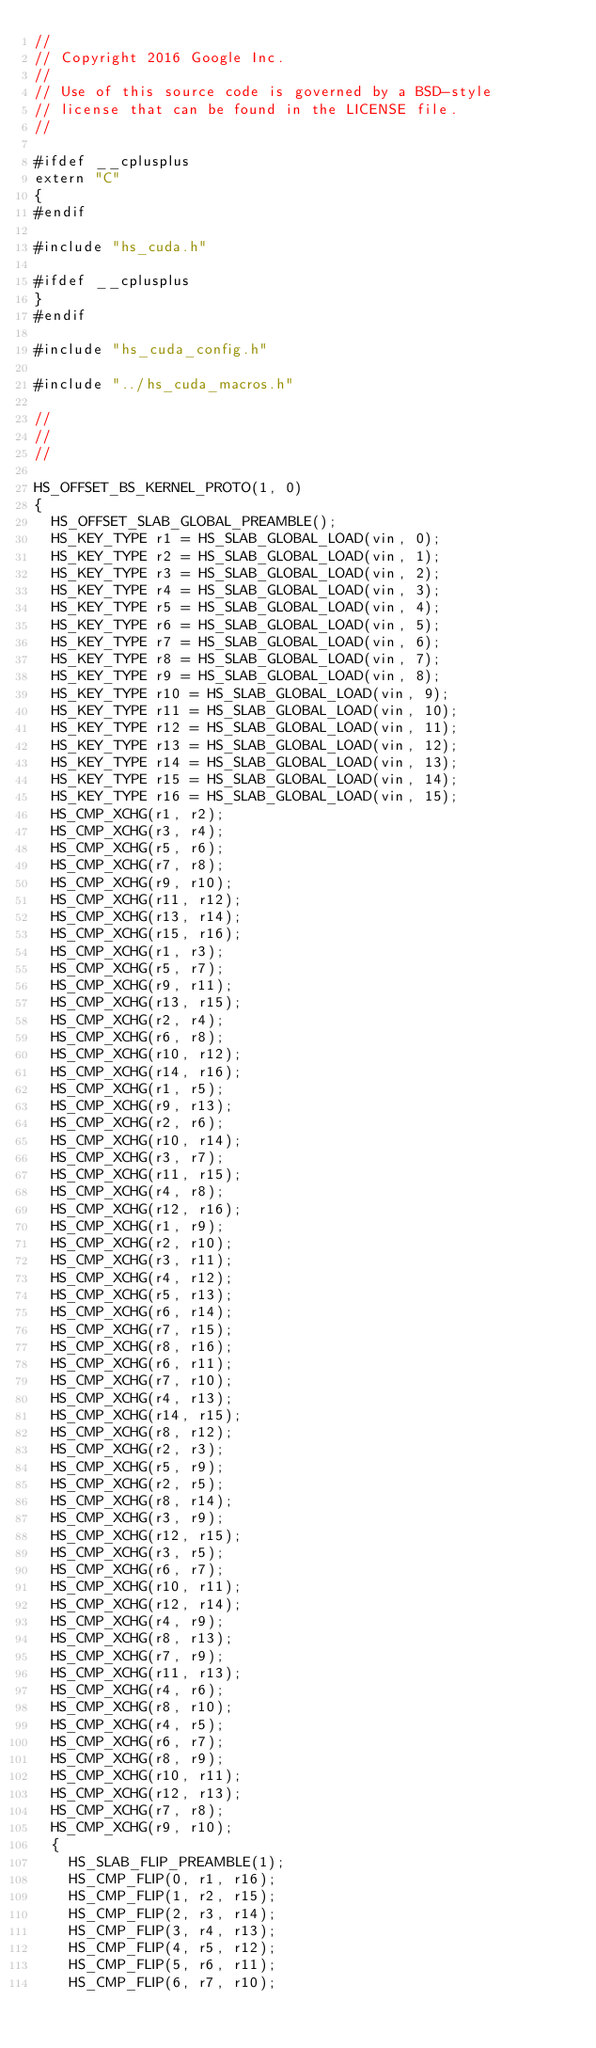Convert code to text. <code><loc_0><loc_0><loc_500><loc_500><_Cuda_>//
// Copyright 2016 Google Inc.
//
// Use of this source code is governed by a BSD-style
// license that can be found in the LICENSE file.
//

#ifdef __cplusplus
extern "C"
{
#endif

#include "hs_cuda.h"

#ifdef __cplusplus
}
#endif

#include "hs_cuda_config.h"

#include "../hs_cuda_macros.h"

//
//
//

HS_OFFSET_BS_KERNEL_PROTO(1, 0)
{
  HS_OFFSET_SLAB_GLOBAL_PREAMBLE();
  HS_KEY_TYPE r1 = HS_SLAB_GLOBAL_LOAD(vin, 0);
  HS_KEY_TYPE r2 = HS_SLAB_GLOBAL_LOAD(vin, 1);
  HS_KEY_TYPE r3 = HS_SLAB_GLOBAL_LOAD(vin, 2);
  HS_KEY_TYPE r4 = HS_SLAB_GLOBAL_LOAD(vin, 3);
  HS_KEY_TYPE r5 = HS_SLAB_GLOBAL_LOAD(vin, 4);
  HS_KEY_TYPE r6 = HS_SLAB_GLOBAL_LOAD(vin, 5);
  HS_KEY_TYPE r7 = HS_SLAB_GLOBAL_LOAD(vin, 6);
  HS_KEY_TYPE r8 = HS_SLAB_GLOBAL_LOAD(vin, 7);
  HS_KEY_TYPE r9 = HS_SLAB_GLOBAL_LOAD(vin, 8);
  HS_KEY_TYPE r10 = HS_SLAB_GLOBAL_LOAD(vin, 9);
  HS_KEY_TYPE r11 = HS_SLAB_GLOBAL_LOAD(vin, 10);
  HS_KEY_TYPE r12 = HS_SLAB_GLOBAL_LOAD(vin, 11);
  HS_KEY_TYPE r13 = HS_SLAB_GLOBAL_LOAD(vin, 12);
  HS_KEY_TYPE r14 = HS_SLAB_GLOBAL_LOAD(vin, 13);
  HS_KEY_TYPE r15 = HS_SLAB_GLOBAL_LOAD(vin, 14);
  HS_KEY_TYPE r16 = HS_SLAB_GLOBAL_LOAD(vin, 15);
  HS_CMP_XCHG(r1, r2);
  HS_CMP_XCHG(r3, r4);
  HS_CMP_XCHG(r5, r6);
  HS_CMP_XCHG(r7, r8);
  HS_CMP_XCHG(r9, r10);
  HS_CMP_XCHG(r11, r12);
  HS_CMP_XCHG(r13, r14);
  HS_CMP_XCHG(r15, r16);
  HS_CMP_XCHG(r1, r3);
  HS_CMP_XCHG(r5, r7);
  HS_CMP_XCHG(r9, r11);
  HS_CMP_XCHG(r13, r15);
  HS_CMP_XCHG(r2, r4);
  HS_CMP_XCHG(r6, r8);
  HS_CMP_XCHG(r10, r12);
  HS_CMP_XCHG(r14, r16);
  HS_CMP_XCHG(r1, r5);
  HS_CMP_XCHG(r9, r13);
  HS_CMP_XCHG(r2, r6);
  HS_CMP_XCHG(r10, r14);
  HS_CMP_XCHG(r3, r7);
  HS_CMP_XCHG(r11, r15);
  HS_CMP_XCHG(r4, r8);
  HS_CMP_XCHG(r12, r16);
  HS_CMP_XCHG(r1, r9);
  HS_CMP_XCHG(r2, r10);
  HS_CMP_XCHG(r3, r11);
  HS_CMP_XCHG(r4, r12);
  HS_CMP_XCHG(r5, r13);
  HS_CMP_XCHG(r6, r14);
  HS_CMP_XCHG(r7, r15);
  HS_CMP_XCHG(r8, r16);
  HS_CMP_XCHG(r6, r11);
  HS_CMP_XCHG(r7, r10);
  HS_CMP_XCHG(r4, r13);
  HS_CMP_XCHG(r14, r15);
  HS_CMP_XCHG(r8, r12);
  HS_CMP_XCHG(r2, r3);
  HS_CMP_XCHG(r5, r9);
  HS_CMP_XCHG(r2, r5);
  HS_CMP_XCHG(r8, r14);
  HS_CMP_XCHG(r3, r9);
  HS_CMP_XCHG(r12, r15);
  HS_CMP_XCHG(r3, r5);
  HS_CMP_XCHG(r6, r7);
  HS_CMP_XCHG(r10, r11);
  HS_CMP_XCHG(r12, r14);
  HS_CMP_XCHG(r4, r9);
  HS_CMP_XCHG(r8, r13);
  HS_CMP_XCHG(r7, r9);
  HS_CMP_XCHG(r11, r13);
  HS_CMP_XCHG(r4, r6);
  HS_CMP_XCHG(r8, r10);
  HS_CMP_XCHG(r4, r5);
  HS_CMP_XCHG(r6, r7);
  HS_CMP_XCHG(r8, r9);
  HS_CMP_XCHG(r10, r11);
  HS_CMP_XCHG(r12, r13);
  HS_CMP_XCHG(r7, r8);
  HS_CMP_XCHG(r9, r10);
  {
    HS_SLAB_FLIP_PREAMBLE(1);
    HS_CMP_FLIP(0, r1, r16);
    HS_CMP_FLIP(1, r2, r15);
    HS_CMP_FLIP(2, r3, r14);
    HS_CMP_FLIP(3, r4, r13);
    HS_CMP_FLIP(4, r5, r12);
    HS_CMP_FLIP(5, r6, r11);
    HS_CMP_FLIP(6, r7, r10);</code> 